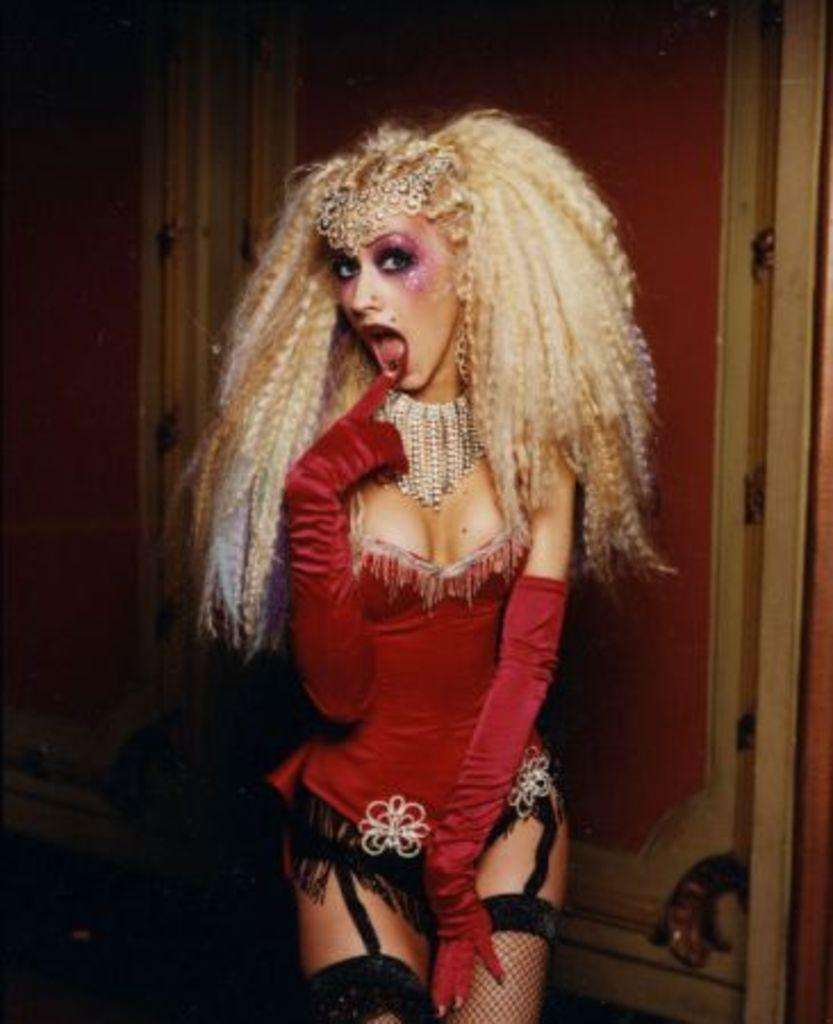What is the main subject of the image? There is a woman standing in the image. Where is the woman positioned in the image? The woman is in the middle of the image. What can be seen behind the woman? There is a wall behind the woman. What type of wound can be seen on the woman's arm in the image? There is no wound visible on the woman's arm in the image. Can you read the note that the woman is holding in the image? There is no note present in the image for the woman to hold. 